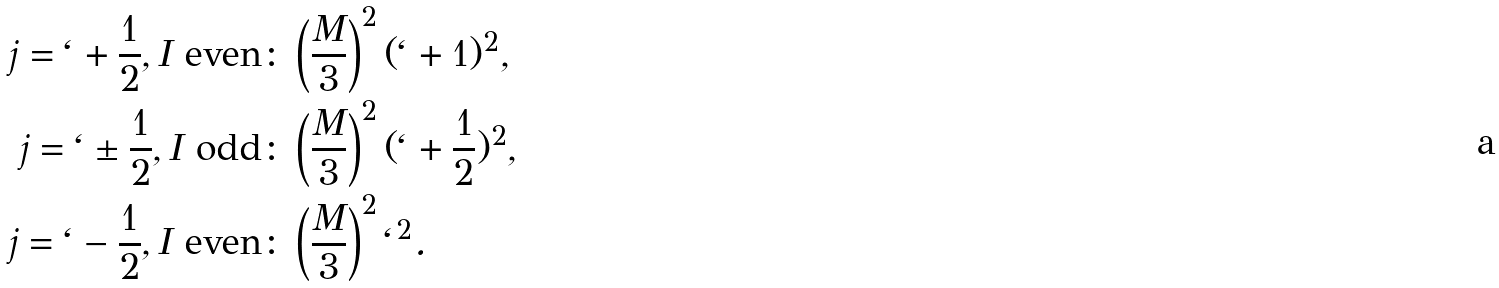<formula> <loc_0><loc_0><loc_500><loc_500>j = \ell + \frac { 1 } { 2 } , I \text { even} \colon & \left ( \frac { M } { 3 } \right ) ^ { 2 } ( \ell + 1 ) ^ { 2 } , \\ j = \ell \pm \frac { 1 } { 2 } , I \text { odd} \colon & \left ( \frac { M } { 3 } \right ) ^ { 2 } ( \ell + \frac { 1 } { 2 } ) ^ { 2 } , \\ j = \ell - \frac { 1 } { 2 } , I \text { even} \colon & \left ( \frac { M } { 3 } \right ) ^ { 2 } \ell ^ { 2 } .</formula> 